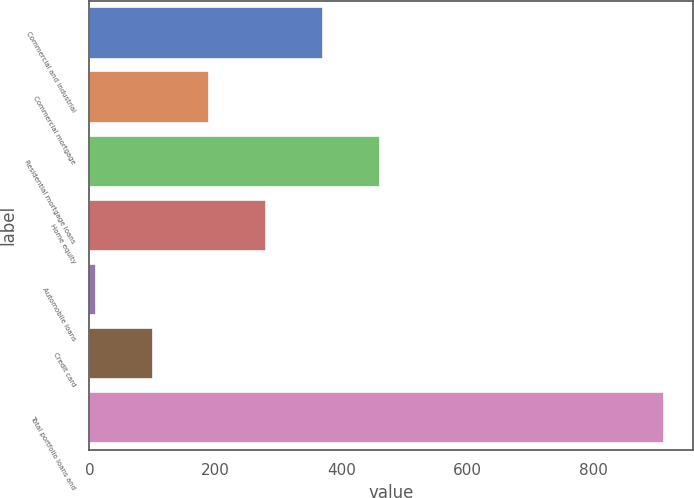<chart> <loc_0><loc_0><loc_500><loc_500><bar_chart><fcel>Commercial and industrial<fcel>Commercial mortgage<fcel>Residential mortgage loans<fcel>Home equity<fcel>Automobile loans<fcel>Credit card<fcel>Total portfolio loans and<nl><fcel>370.8<fcel>190.4<fcel>461<fcel>280.6<fcel>10<fcel>100.2<fcel>912<nl></chart> 